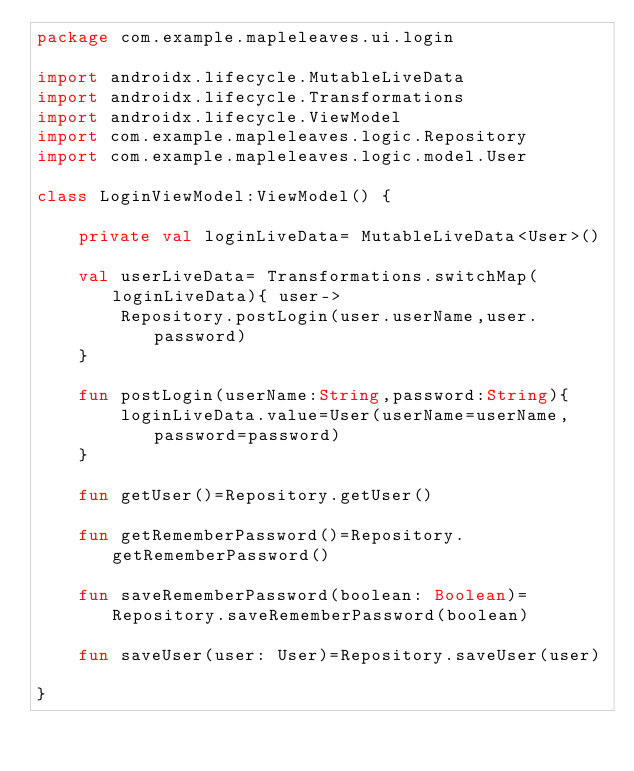<code> <loc_0><loc_0><loc_500><loc_500><_Kotlin_>package com.example.mapleleaves.ui.login

import androidx.lifecycle.MutableLiveData
import androidx.lifecycle.Transformations
import androidx.lifecycle.ViewModel
import com.example.mapleleaves.logic.Repository
import com.example.mapleleaves.logic.model.User

class LoginViewModel:ViewModel() {

    private val loginLiveData= MutableLiveData<User>()

    val userLiveData= Transformations.switchMap(loginLiveData){ user->
        Repository.postLogin(user.userName,user.password)
    }

    fun postLogin(userName:String,password:String){
        loginLiveData.value=User(userName=userName,password=password)
    }

    fun getUser()=Repository.getUser()

    fun getRememberPassword()=Repository.getRememberPassword()

    fun saveRememberPassword(boolean: Boolean)=Repository.saveRememberPassword(boolean)

    fun saveUser(user: User)=Repository.saveUser(user)

}</code> 